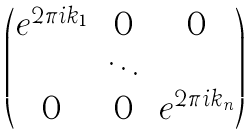<formula> <loc_0><loc_0><loc_500><loc_500>\begin{pmatrix} e ^ { 2 \pi i k _ { 1 } } & 0 & 0 \\ & \ddots & \\ 0 & 0 & e ^ { 2 \pi i k _ { n } } \end{pmatrix}</formula> 